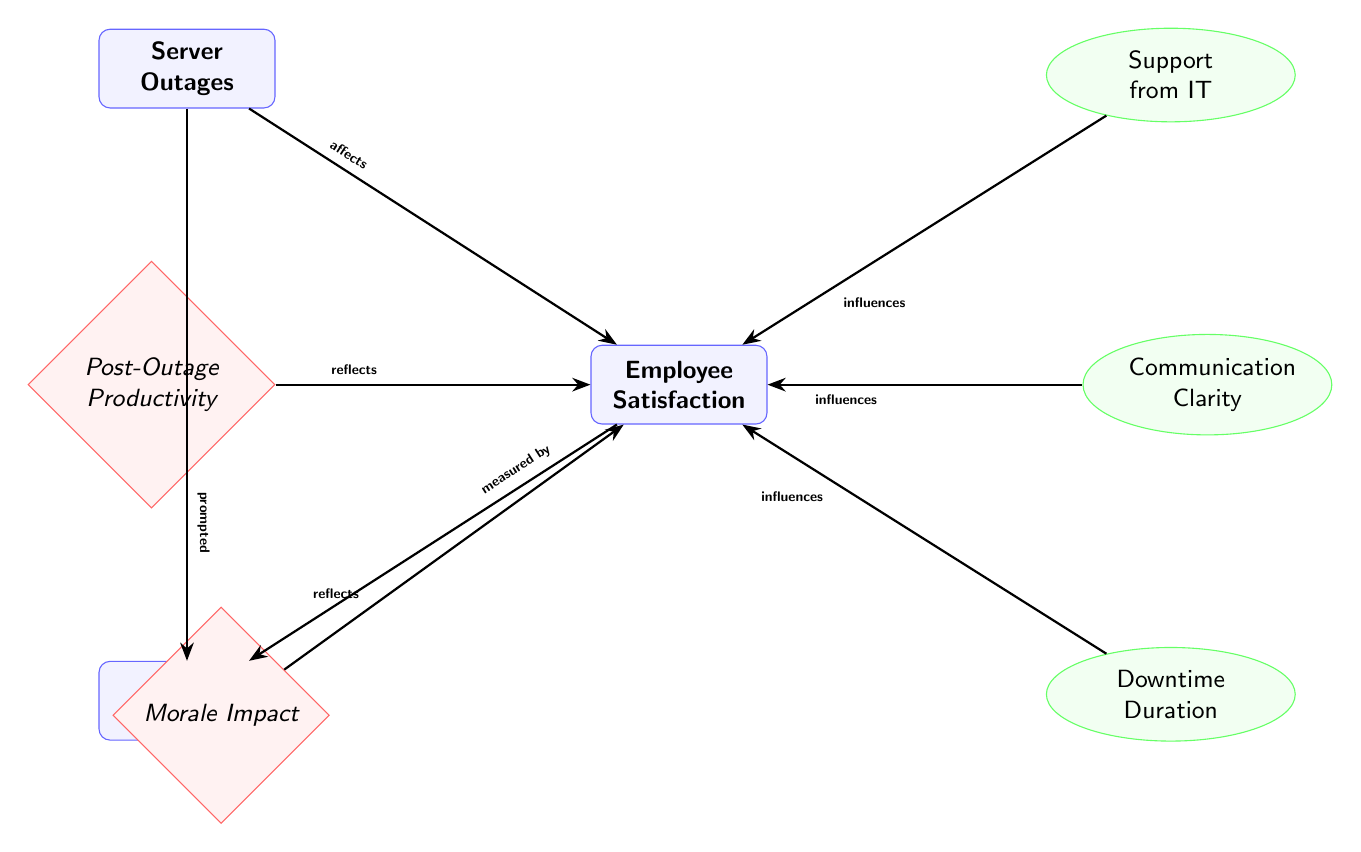What is the main entity that affects employee satisfaction? The diagram indicates that "Server Outages" is the primary entity affecting "Employee Satisfaction," as it connects directly to this node with the label "affects."
Answer: Server Outages How many factors influence employee satisfaction? Upon reviewing the diagram, there are three factors listed that influence employee satisfaction: "Support from IT," "Communication Clarity," and "Downtime Duration."
Answer: Three What does the survey reflect in relation to employee satisfaction? The diagram specifies that "Morale Impact" and "Post-Outage Productivity" both reflect the state of "Employee Satisfaction," indicating how satisfaction is viewed in terms of morale and productivity post-outage.
Answer: Morale Impact and Post-Outage Productivity Which factor has been prompted by server outages? The diagram shows that the "Survey Results" are prompted by "Server Outages," indicating that outages lead to the collection of survey information.
Answer: Survey Results How does downtime duration affect employee satisfaction? The diagram states that "Downtime Duration" influences "Employee Satisfaction," indicating that the length of downtime has a direct impact on how satisfied employees feel.
Answer: Influences Which outcome does support from IT influence directly? Reviewing the diagram, it is clear that "Support from IT" influences "Employee Satisfaction" directly, indicating a connection between IT support and employee contentment.
Answer: Employee Satisfaction What is measured by survey results in this diagram? According to the diagram, "Survey Results" measure "Employee Satisfaction," showing that employee feedback reflects their satisfaction levels.
Answer: Employee Satisfaction What is the relationship between morale and employee satisfaction? The diagram shows that "Morale Impact" reflects "Employee Satisfaction," which suggests that employee satisfaction levels are reflected in their morale during outages.
Answer: Reflects What do server outages prompt in addition to impacting satisfaction? The diagram clearly states that server outages prompted "Survey Results," indicating a dual effect where outages not only affect satisfaction but also lead to collecting survey data.
Answer: Survey Results 